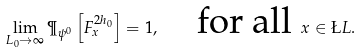<formula> <loc_0><loc_0><loc_500><loc_500>\lim _ { L _ { 0 } \to \infty } \P _ { \psi ^ { 0 } } \left [ F _ { x } ^ { 2 h _ { 0 } } \right ] = 1 , \quad \text {for all } x \in \L L .</formula> 